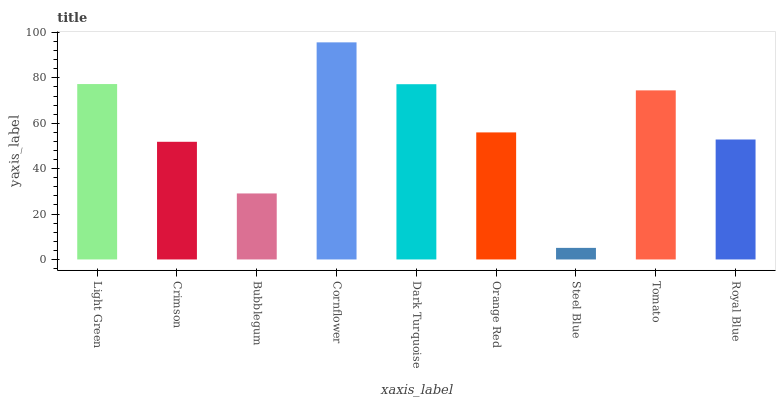Is Steel Blue the minimum?
Answer yes or no. Yes. Is Cornflower the maximum?
Answer yes or no. Yes. Is Crimson the minimum?
Answer yes or no. No. Is Crimson the maximum?
Answer yes or no. No. Is Light Green greater than Crimson?
Answer yes or no. Yes. Is Crimson less than Light Green?
Answer yes or no. Yes. Is Crimson greater than Light Green?
Answer yes or no. No. Is Light Green less than Crimson?
Answer yes or no. No. Is Orange Red the high median?
Answer yes or no. Yes. Is Orange Red the low median?
Answer yes or no. Yes. Is Dark Turquoise the high median?
Answer yes or no. No. Is Steel Blue the low median?
Answer yes or no. No. 